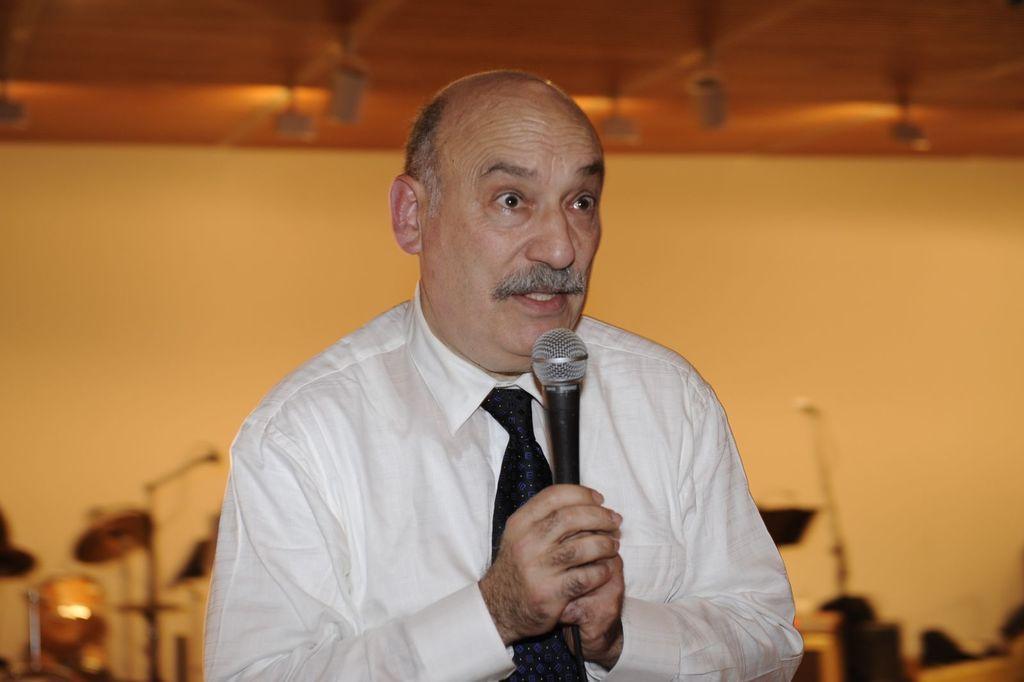Please provide a concise description of this image. A man is speaking in the microphone. He wear a shirt,tie. 